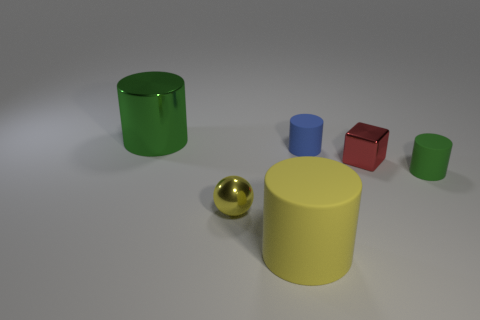Is there any other thing that is the same size as the green rubber object?
Offer a very short reply. Yes. Are there fewer rubber things that are in front of the tiny yellow metallic thing than tiny things that are in front of the small red metal thing?
Your response must be concise. Yes. Is the material of the tiny green cylinder the same as the big cylinder that is in front of the small green object?
Ensure brevity in your answer.  Yes. Are there more tiny green matte things than green spheres?
Offer a terse response. Yes. What shape is the green object that is in front of the small shiny object on the right side of the rubber cylinder that is in front of the yellow metallic ball?
Give a very brief answer. Cylinder. Is the green cylinder that is behind the small blue cylinder made of the same material as the yellow object on the left side of the yellow matte cylinder?
Your response must be concise. Yes. What shape is the yellow object that is the same material as the large green thing?
Provide a short and direct response. Sphere. Is there any other thing that is the same color as the ball?
Give a very brief answer. Yes. What number of large matte cubes are there?
Your answer should be very brief. 0. There is a green object to the right of the green object that is left of the large yellow matte thing; what is its material?
Offer a very short reply. Rubber. 